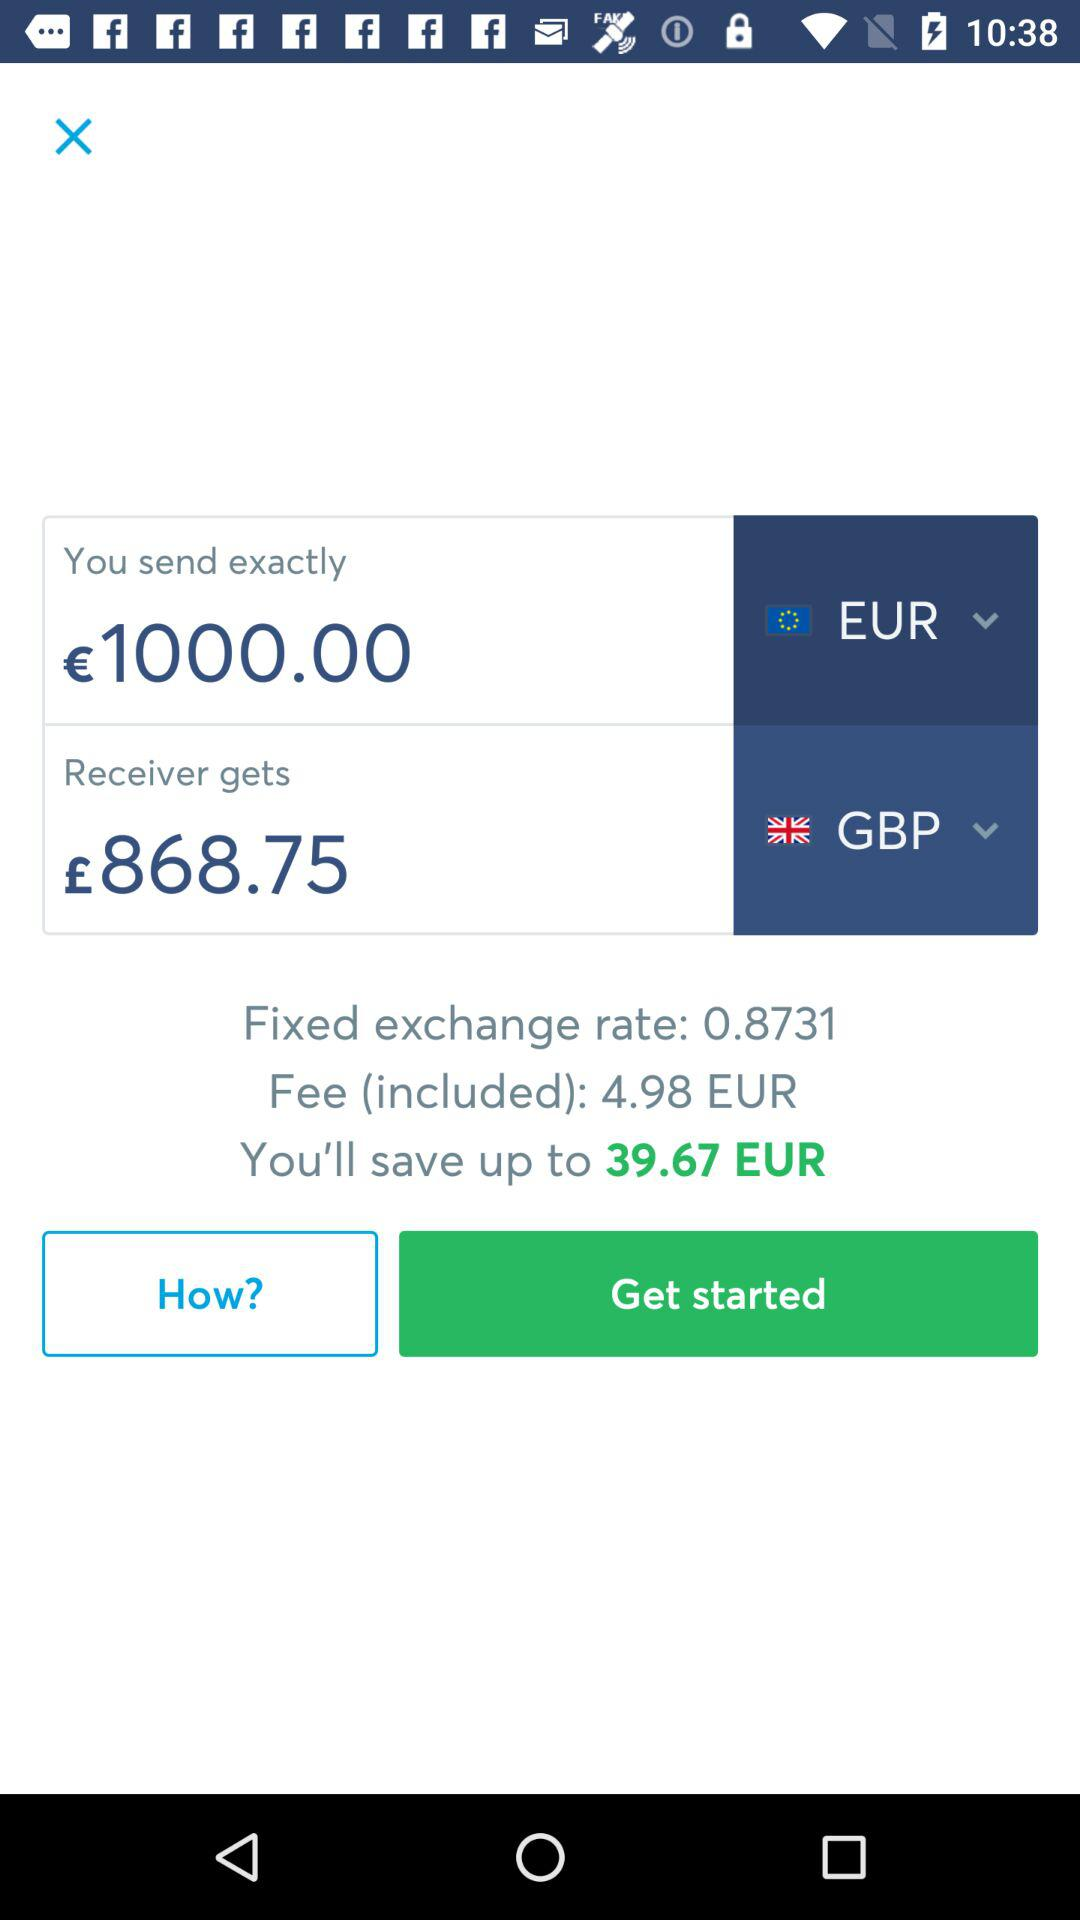What is the fee for transferring the money? The fee for transferring the money is 4.98 EUR. 